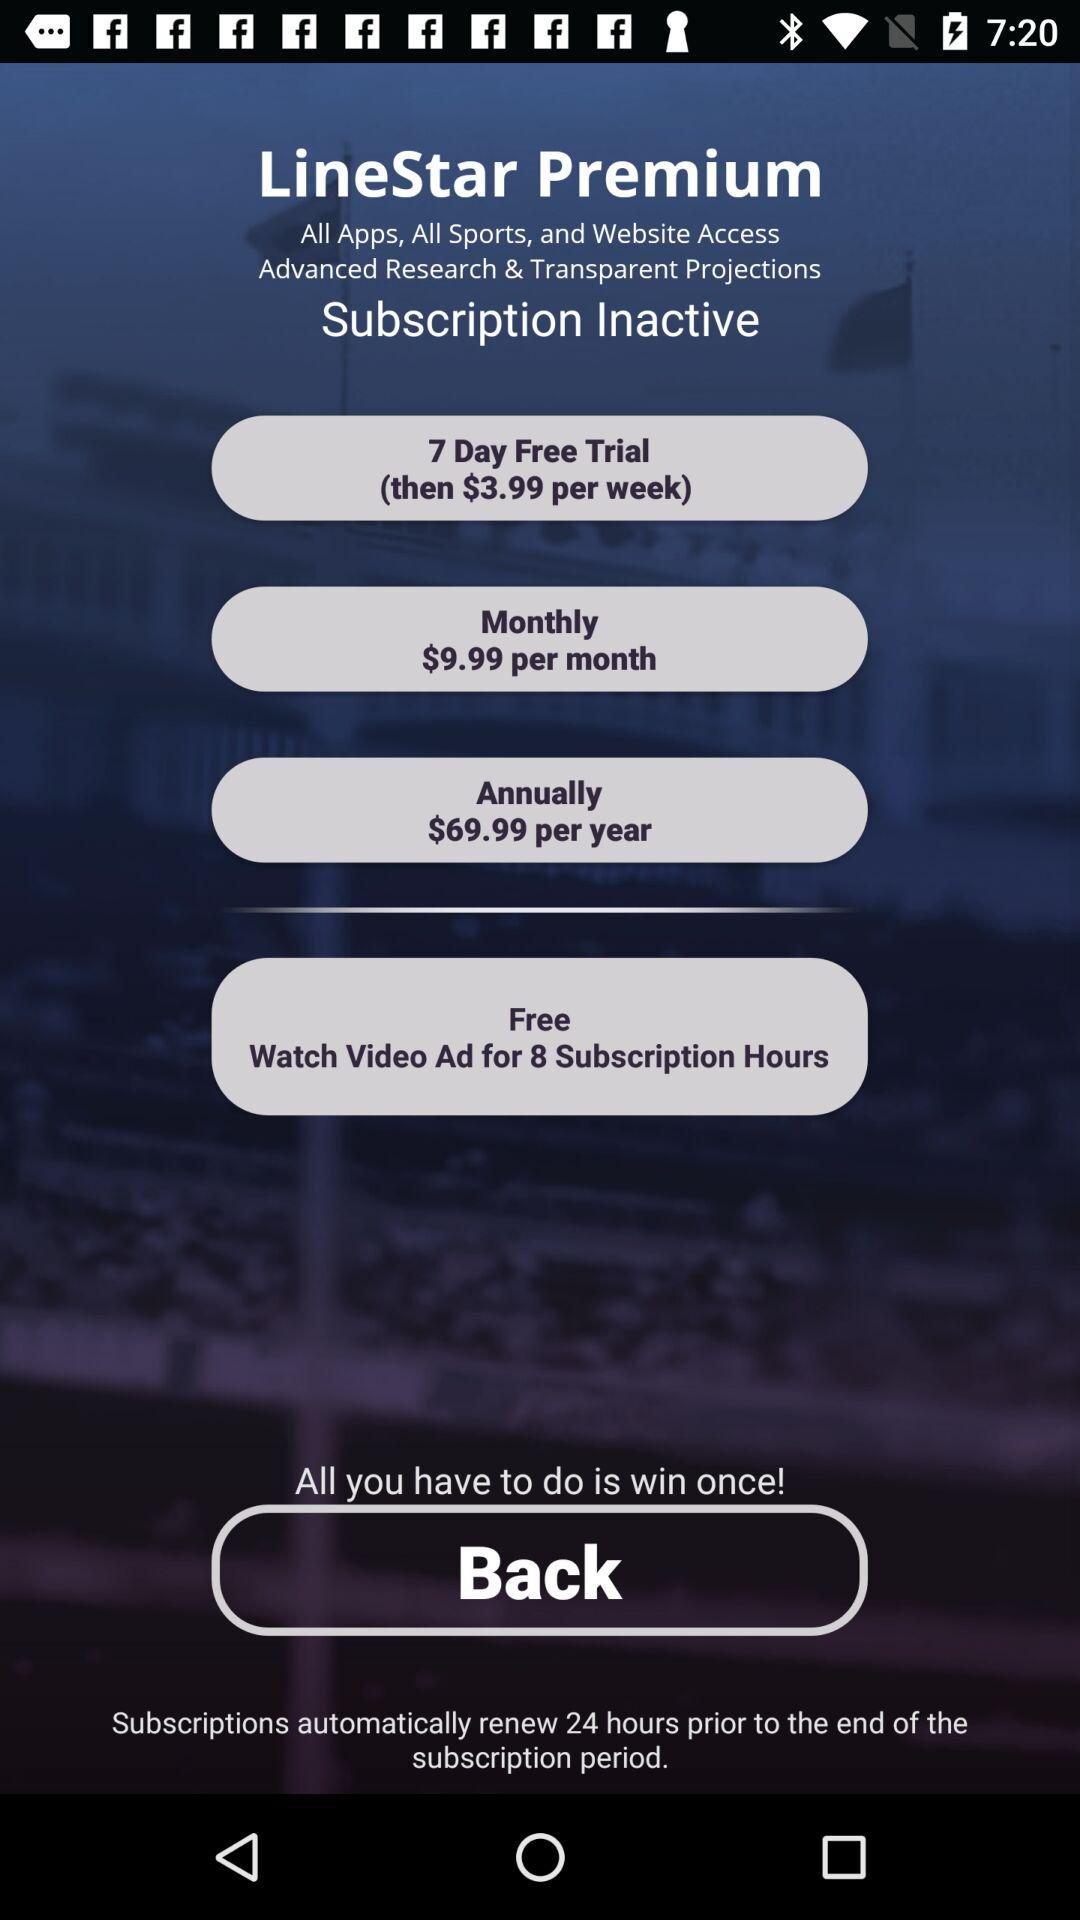What is the offer available for the free "8 subscription hours"? The offer is to watch a video ad. 